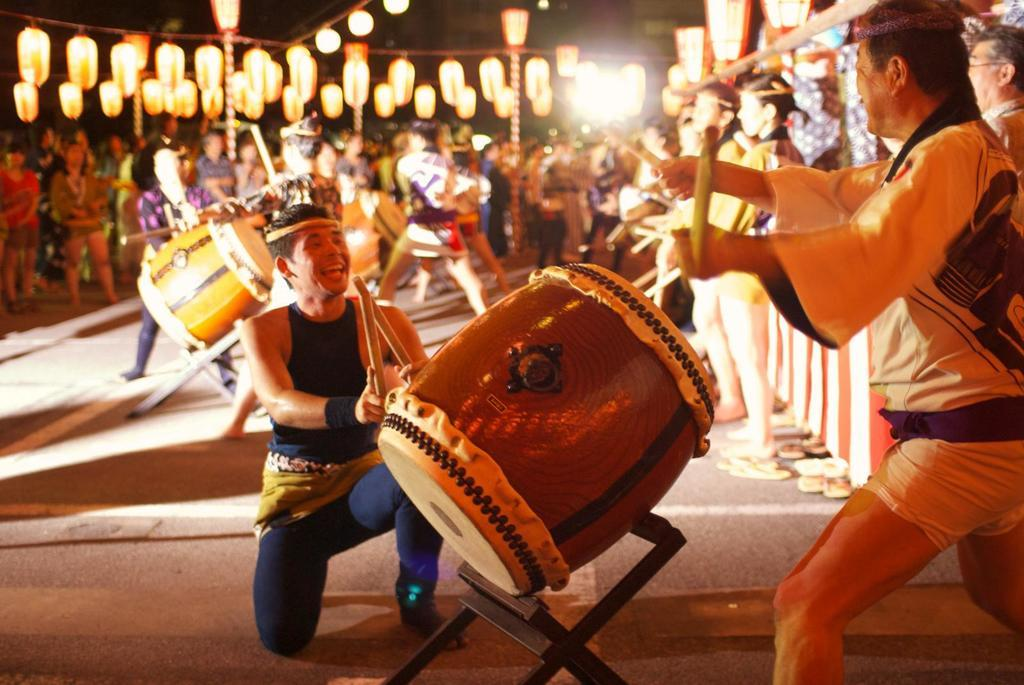What are the men in the image doing? The men in the image are playing drums. What event might be taking place in the image? It appears to be a festival in the image. What can be seen hanging from the top in the image? There are lights hanging from the top in the image. What type of muscle is being exercised by the men playing drums in the image? There is no specific muscle being exercised by the men playing drums in the image, as the focus is on their drumming performance. 